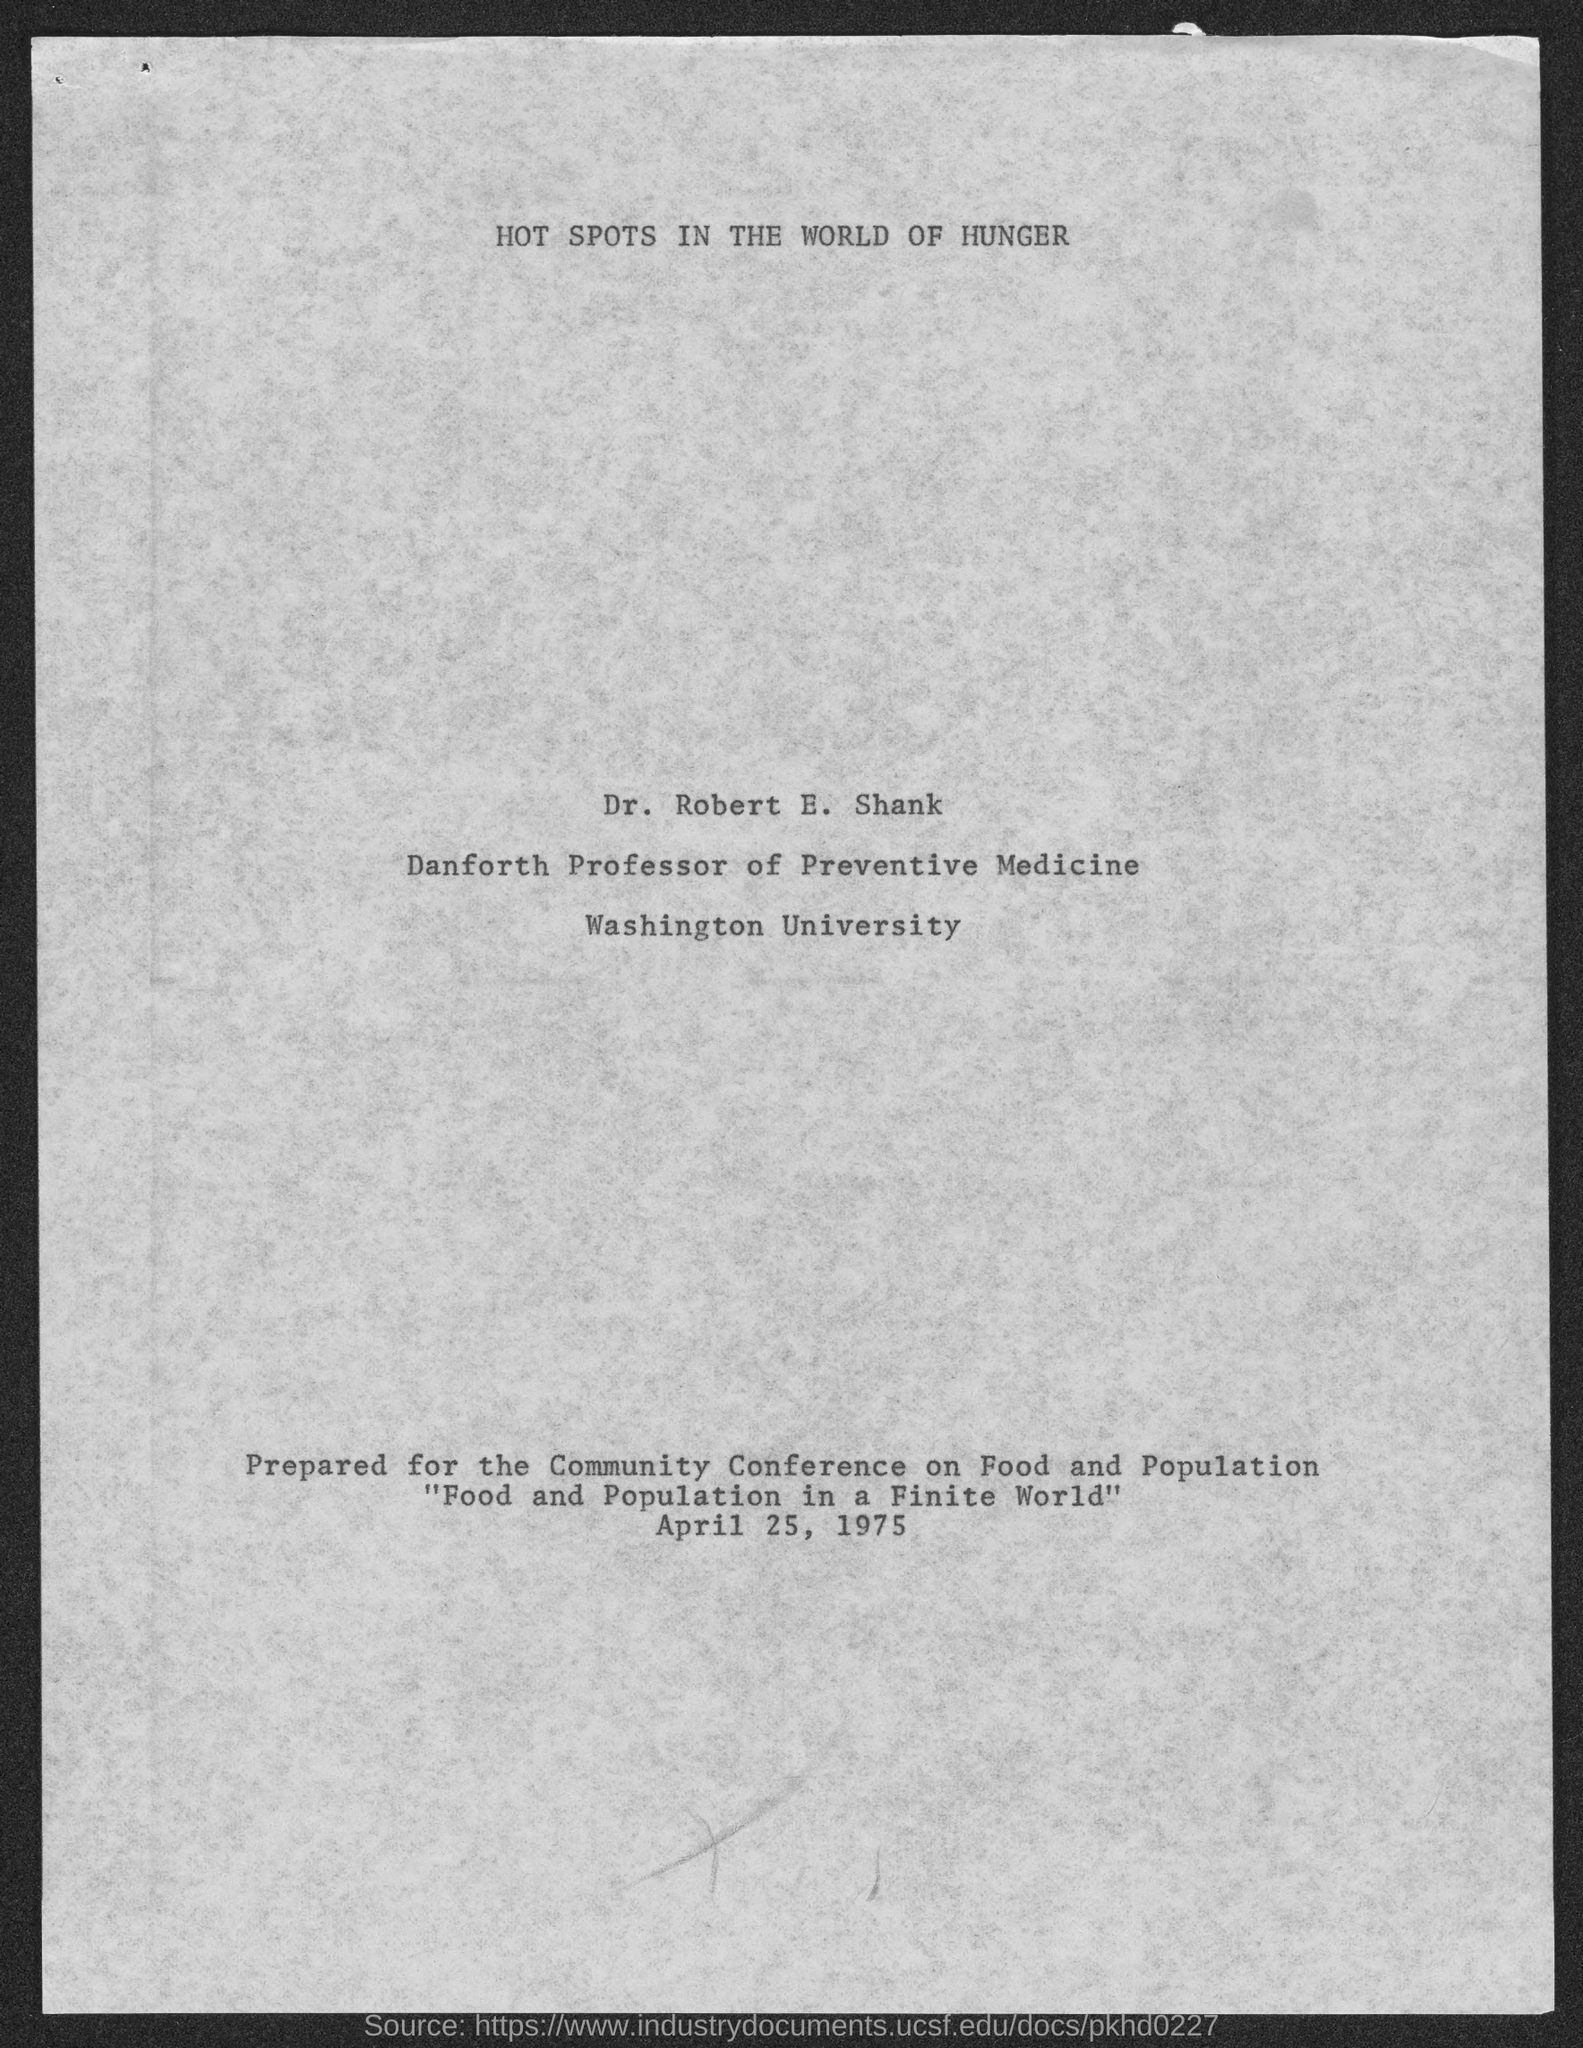Indicate a few pertinent items in this graphic. Dr. Robert E. Shank is the Danforth Professor of Preventive Medicine. Dr. Robert E. Shank belongs to Washington University. 